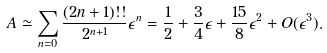Convert formula to latex. <formula><loc_0><loc_0><loc_500><loc_500>A \simeq \sum _ { n = 0 } \frac { ( 2 n + 1 ) ! ! } { 2 ^ { n + 1 } } \epsilon ^ { n } = \frac { 1 } { 2 } + \frac { 3 } { 4 } \epsilon + \frac { 1 5 } { 8 } \epsilon ^ { 2 } + O ( \epsilon ^ { 3 } ) .</formula> 